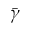<formula> <loc_0><loc_0><loc_500><loc_500>\bar { \gamma }</formula> 